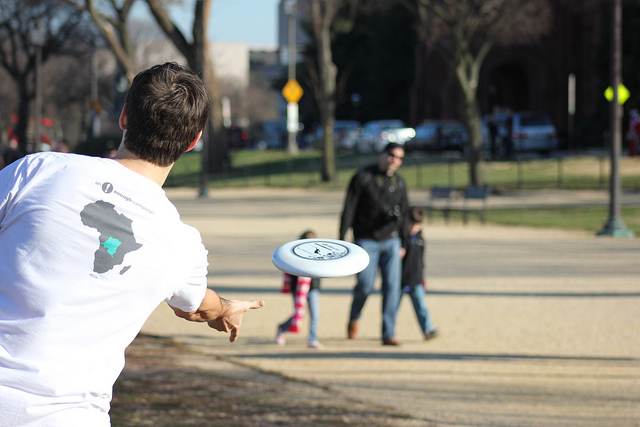Can you describe the environment where this activity is taking place? Certainly! The activity is occurring in an open outdoor area with ample space for the frisbee to fly. The ground appears to be covered with grass, while trees and a clear sky are visible in the background, suggesting a park-like setting. There's also a pedestrian path on one side, and what looks like a city skyline on the horizon. 